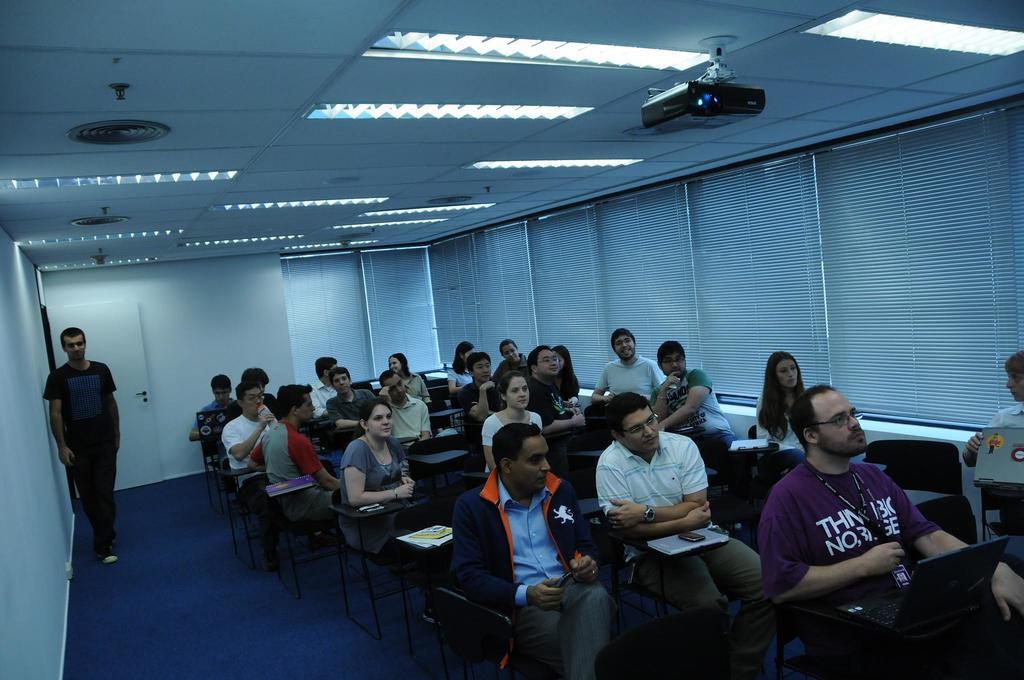How would you summarize this image in a sentence or two? In this image there are people sitting on chairs, on the left side there is wall near the wall a person standing, in the background there is a wall for that wall there is a door and curtains, at the top there are lights, ceiling and projector. 